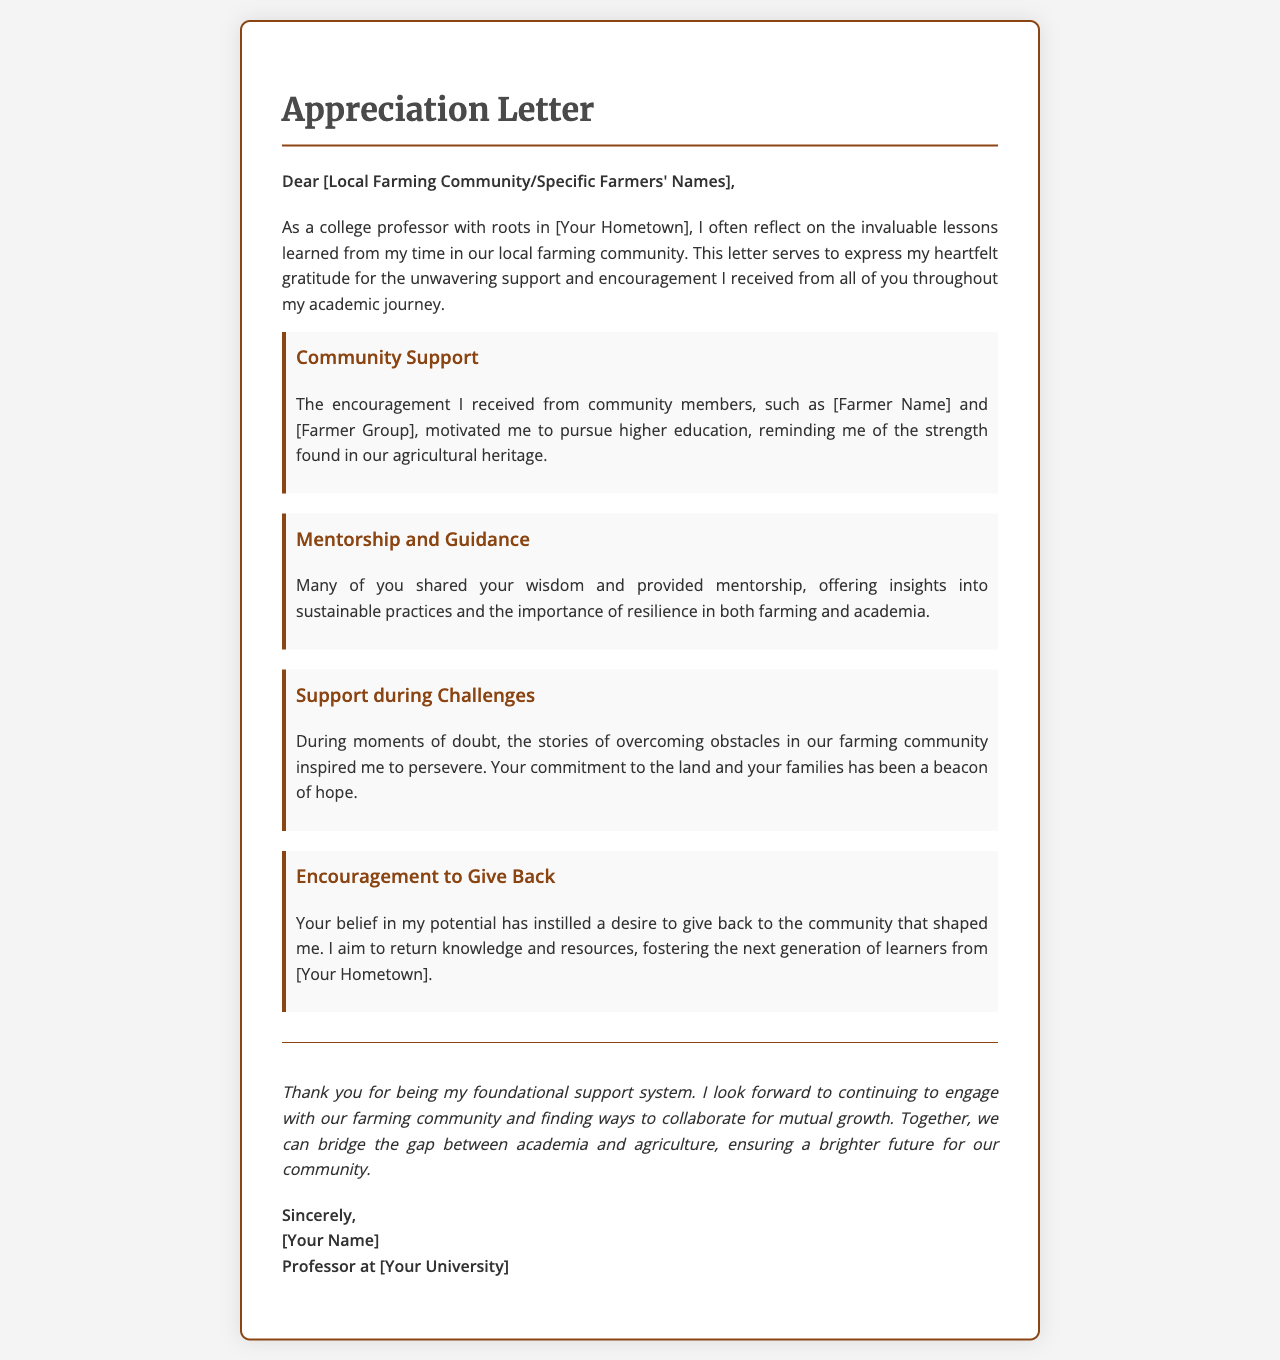what is the title of the document? The title of the document is indicated prominently in the header section.
Answer: Appreciation Letter who is the intended recipient of the letter? The letter is addressed to the local farming community or specific farmers, as indicated in the greeting.
Answer: Local Farming Community what hometown does the author reference? The author mentions their roots in the introduction, referring to their hometown.
Answer: [Your Hometown] which farmer's name is mentioned as part of the community support? The author includes a placeholder for an individual farmer's name in the context of community support.
Answer: [Farmer Name] how has the community inspired the author during challenges? The author expresses how stories from the farming community provided inspiration during difficult times.
Answer: Overcoming obstacles what is the author's profession? The author's occupation is stated at the end of the letter, identifying their role in academia.
Answer: Professor what is the main theme of the letter? The document discusses appreciation and gratitude for support received throughout the author's academic journey, highlighting community connections.
Answer: Appreciation and gratitude what future goal does the author express in the letter? The author mentions a desire to give back to the community that shaped them, indicating a long-term commitment.
Answer: Give back to the community what does the author look forward to in the conclusion? In the conclusion, the author expresses a desire to continue engagement with the community and collaboration for future growth.
Answer: Collaborate for mutual growth 